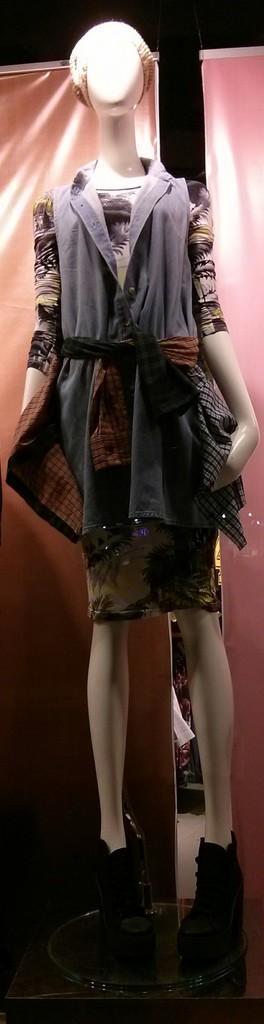Could you give a brief overview of what you see in this image? In this image we can see a mannequin to which there is a costume and also we can see some light shadow on it. 